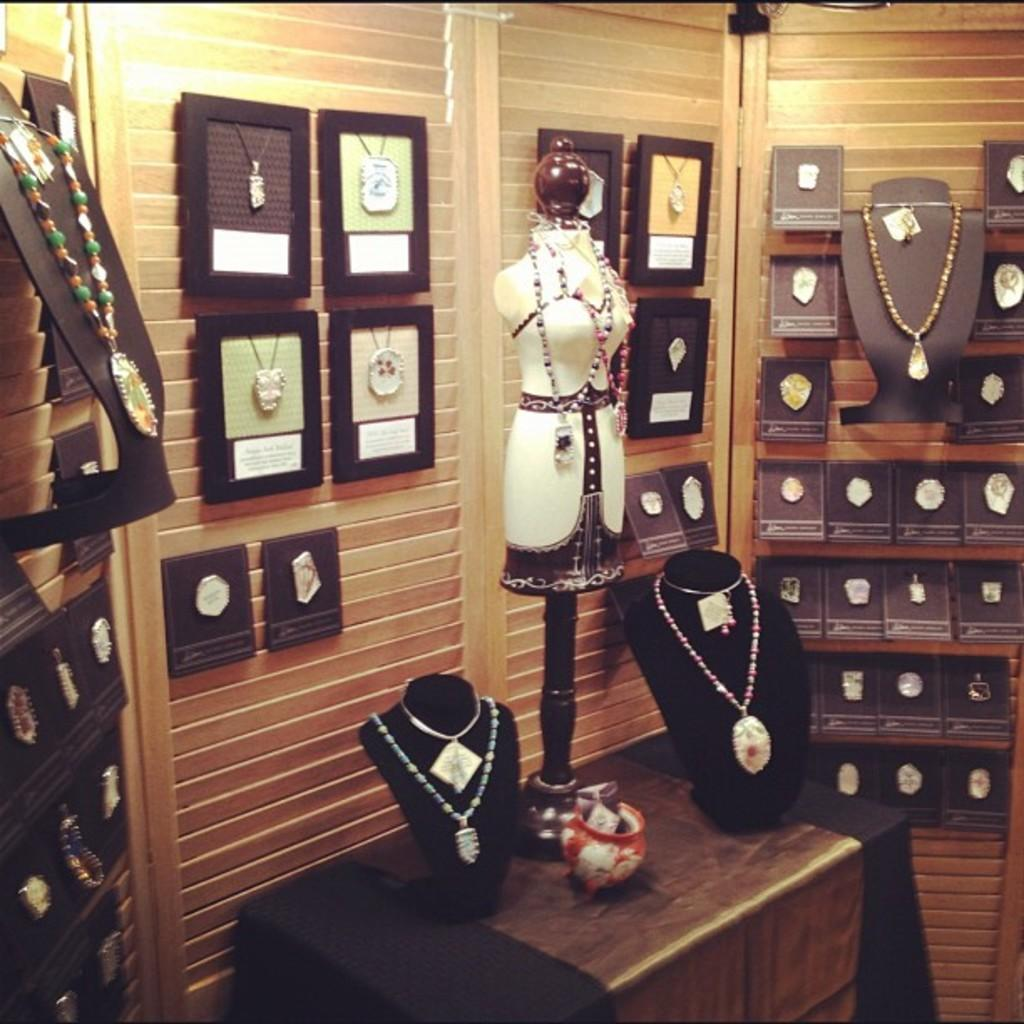What is placed on the table in the image? There are mannequins on a table in the image. What is unique about the mannequins in the image? The mannequins have chains on them. What can be seen in the background of the image? There are chains with frames and boxes in the background of the image. How are the chains connected to the wooden object? These chains are attached to a wooden object. What type of line can be seen in the image? There is no line present in the image. What activity is the person in the image engaged in? There is no person present in the image, only mannequins. 